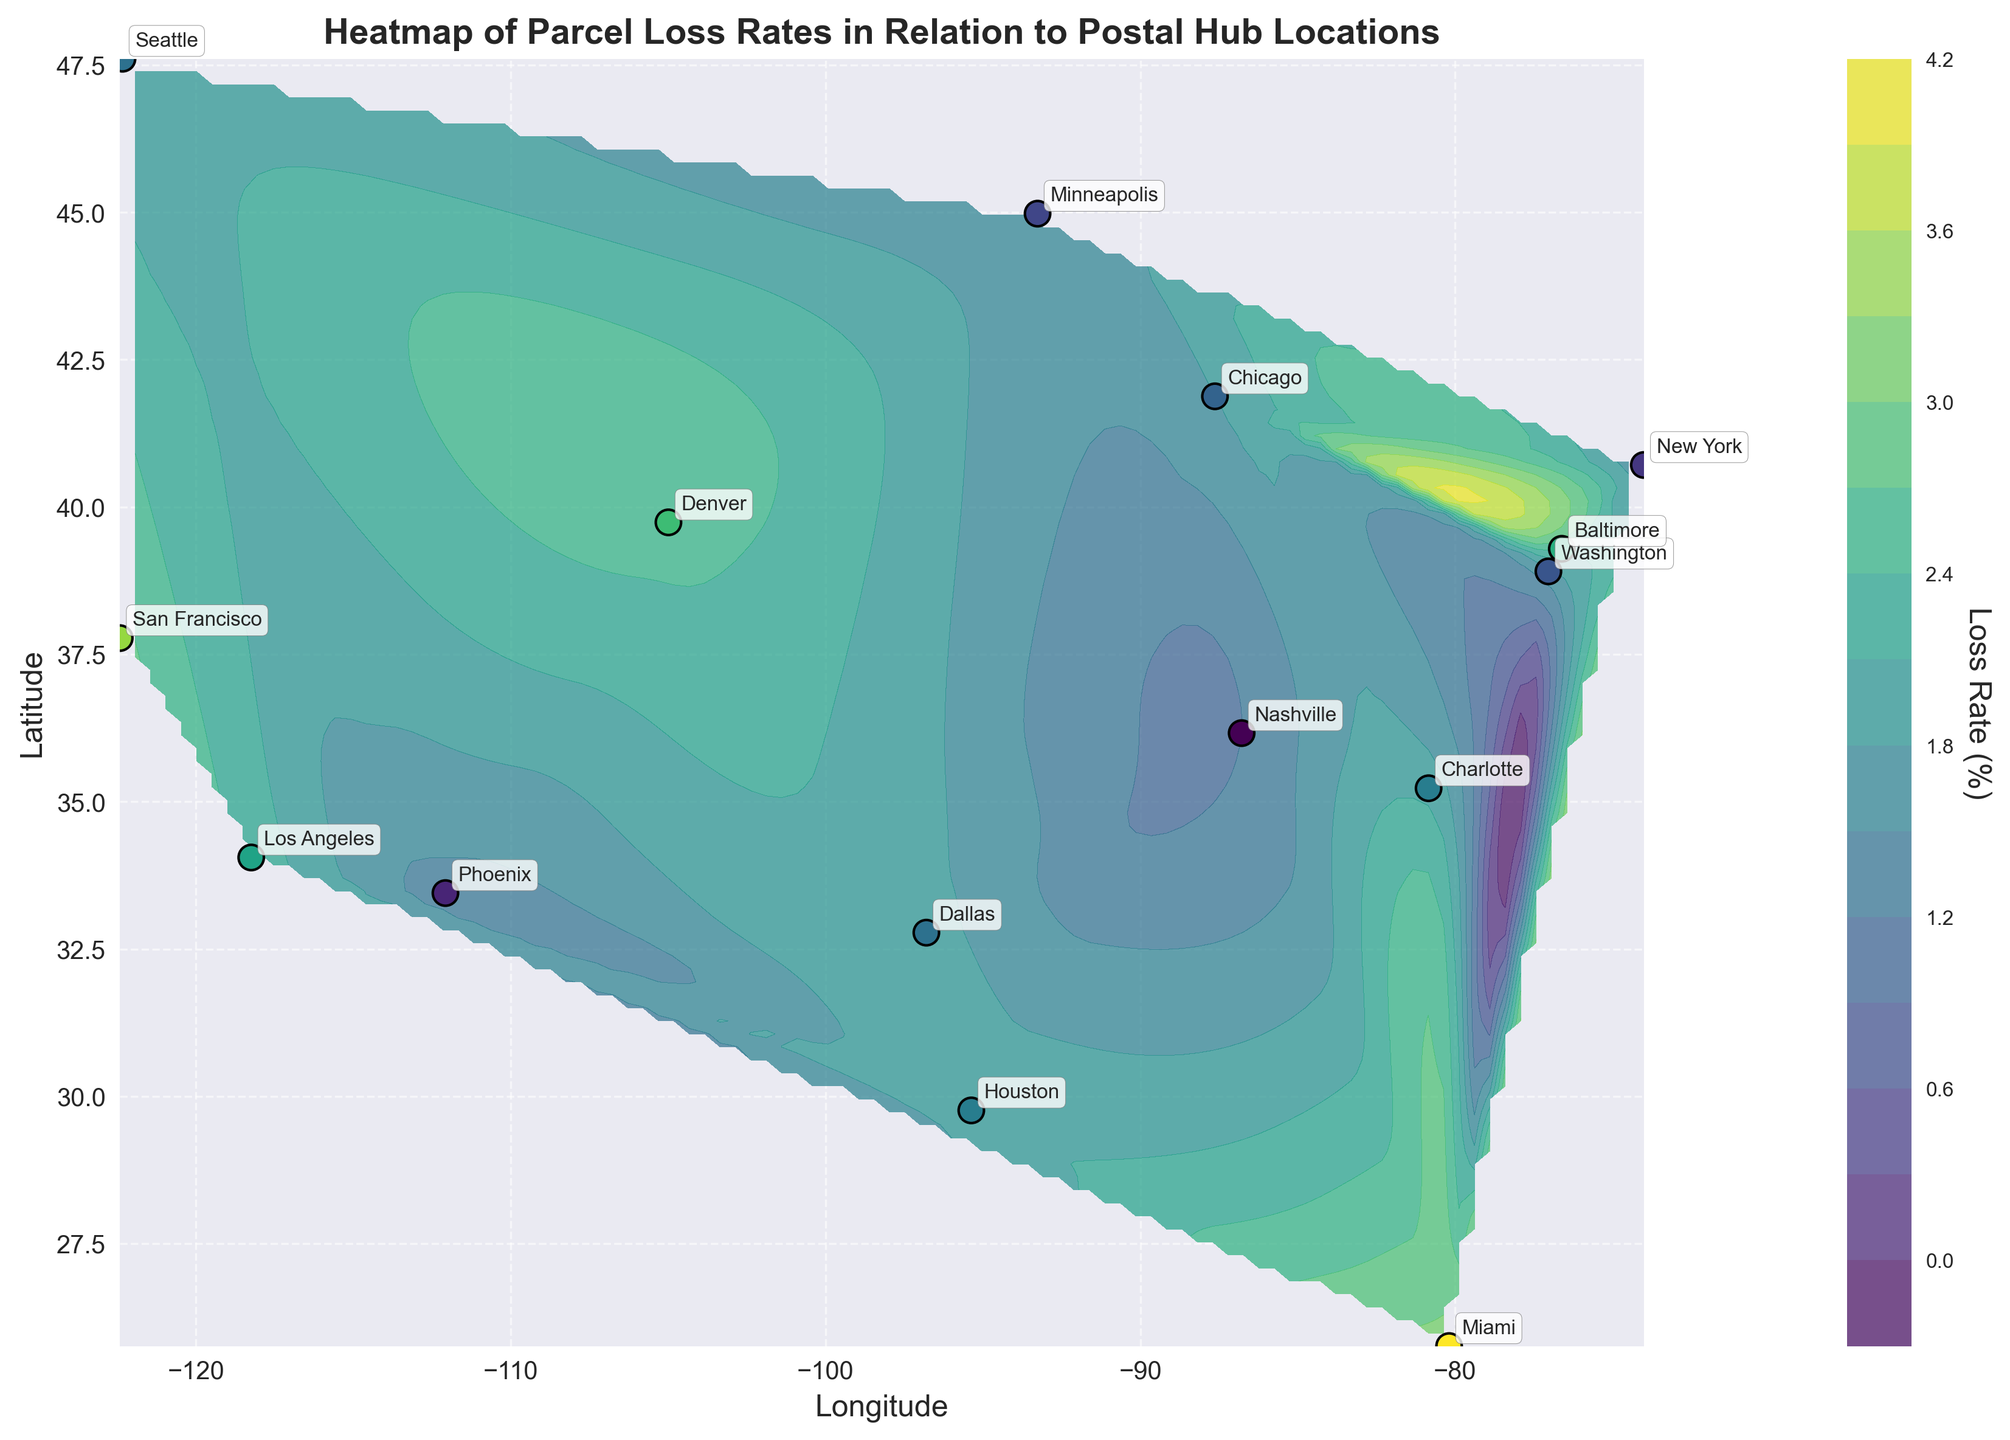What's the title of the figure? The title is displayed at the top of the figure. It states what the plot is about.
Answer: Heatmap of Parcel Loss Rates in Relation to Postal Hub Locations What does the colorbar represent? The colorbar, usually located on the side of the plot, indicates the range of values represented by different colors in the contour plot.
Answer: Loss Rate (%) Which city experiences the highest parcel loss rate? Locate the scatter points representing each city and check their annotated labels. Then, look at the color associated with each point to determine the highest loss rate. Miami appears to have the highest value, denoted in the color gradient.
Answer: Miami Compare the parcel loss rates between New York and Los Angeles. Which one is higher and by how much? Find New York and Los Angeles on the plot and note their associated loss rates. New York has a loss rate of 1.5% and Los Angeles has 2.3%. Subtract the New York rate from the Los Angeles rate (2.3 - 1.5).
Answer: Los Angeles, by 0.8% Which city has the lowest parcel loss rate? Look at the scatter plot and identify the city with the lowest value on the color gradient. Check the annotations for confirmation. Nashville appears to be the lowest.
Answer: Nashville What is the average parcel loss rate across all cities? Identify and sum the loss rates of all cities from the annotations, then divide by the number of cities (15). Calculation: (1.5 + 2.3 + 1.8 + 2.0 + 1.4 + 2.5 + 3.1 + 1.9 + 1.7 + 1.6 + 2.8 + 1.9 + 1.2 + 2.0 + 2.4) / 15.
Answer: 2.00% Identify the region with the highest concentration of postal hubs with loss rates above 2.5%. Observe the contour areas with colors representing loss rates above 2.5%. Then, focus on the annotations to see if there are any cities clustering in that region. The plot shows that the Western U.S. around cities like San Francisco and Denver has higher loss rates.
Answer: Western U.S Looking at the contour lines, which regions have similar parcel loss rates clustered around 2%? Check for contour lines that are labeled or visually represent approximately 2%. Note the areas and corresponding city annotations within these lines. The central U.S. around cities like Chicago, Houston, and Charlotte shows this pattern.
Answer: Central U.S What is the longitude and latitude range represented in the plot? Examine the x-axis (Longitude) and y-axis (Latitude) to determine the range of values covered.
Answer: Longitude: -122.419418 to -74.005974, Latitude: 25.761681 to 47.606209 Which cities are located in regions where the loss rate is between 1% and 2%? Identify the parts of the contour plot where the color gradient corresponds to values between 1% and 2%, then check the annotations of cities in those regions. Cities like New York, Chicago, Phoenix, and Washington fall into this range.
Answer: New York, Chicago, Phoenix, Washington 